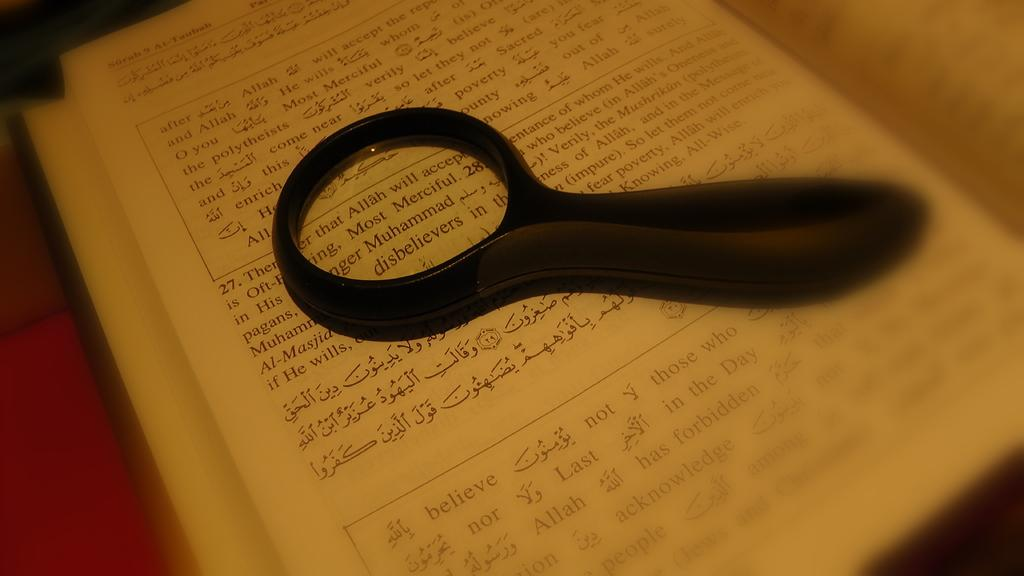<image>
Give a short and clear explanation of the subsequent image. A magnifying glass shows the word disbelievers on a page. 